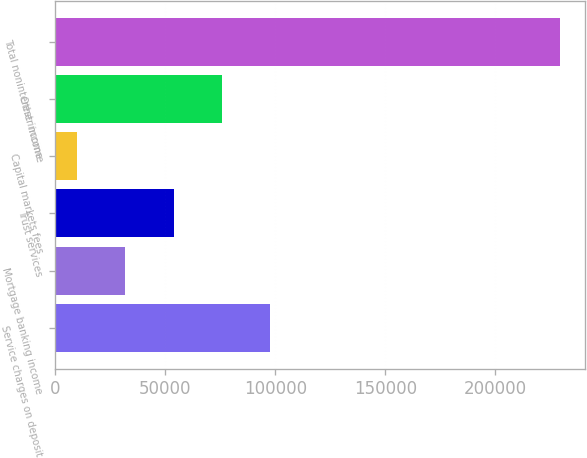Convert chart. <chart><loc_0><loc_0><loc_500><loc_500><bar_chart><fcel>Service charges on deposit<fcel>Mortgage banking income<fcel>Trust services<fcel>Capital markets fees<fcel>Other income<fcel>Total noninterest income<nl><fcel>97627.4<fcel>31765.1<fcel>53719.2<fcel>9811<fcel>75673.3<fcel>229352<nl></chart> 